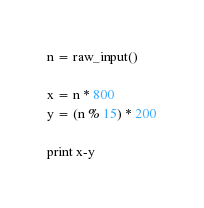Convert code to text. <code><loc_0><loc_0><loc_500><loc_500><_Python_>n = raw_input()

x = n * 800
y = (n % 15) * 200

print x-y</code> 